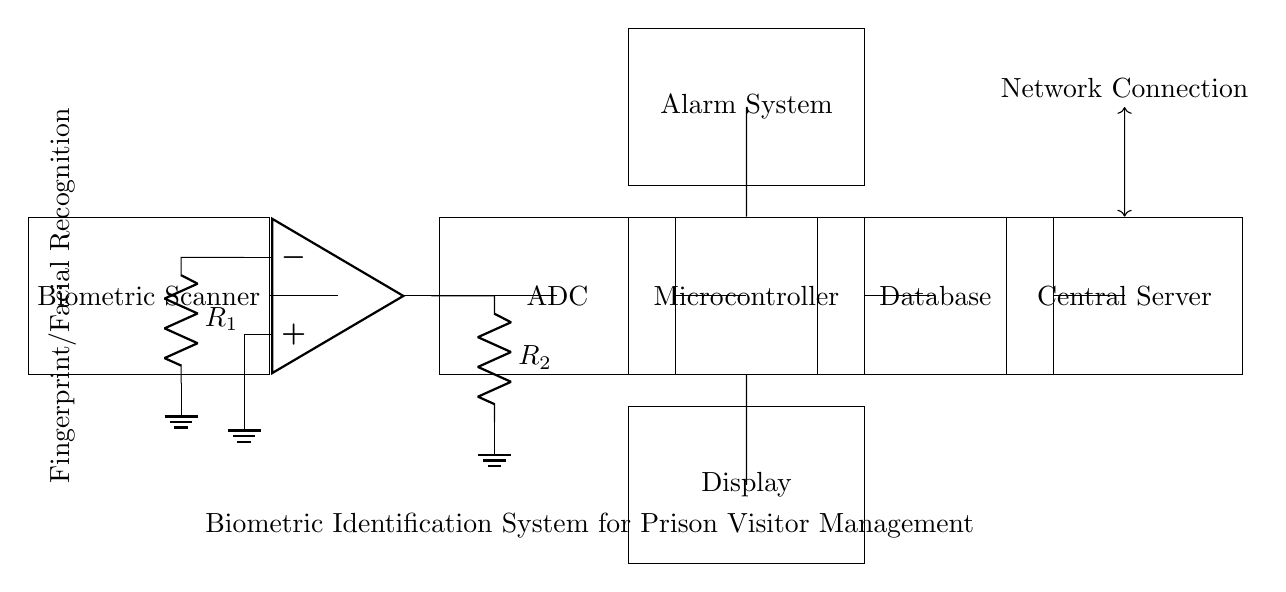What is the first component in the circuit? The first component to appear in the circuit is the Biometric Scanner, which is responsible for capturing biometric data.
Answer: Biometric Scanner How many resistors are present in the circuit? There are two resistors labeled R1 and R2 in the circuit, which are indicated next to the operational amplifier's connections.
Answer: Two What is the output of the operational amplifier connected to? The output of the operational amplifier is connected to the ADC, which converts the analog signal from the op-amp into a digital format for processing.
Answer: ADC Which component is responsible for data storage? The database component is responsible for the storage of biometric data and visitor information processed by the microcontroller.
Answer: Database What is the function of the alarm system in this circuit? The alarm system is designed to alert security personnel of any unauthorized attempts to use biometric data or access the prison inappropriately, as indicated by its connection to the microcontroller.
Answer: Alert Explain the flow of data from the biometric scanner to the central server. The process starts with the Biometric Scanner capturing data, which is then amplified by the operational amplifier. The ADC converts the amplified analog signal into digital form for the microcontroller. The microcontroller processes the data and stores it in the database. Finally, the server receives the data over a network connection for central management and analysis.
Answer: Scanner to Op-amp to ADC to Microcontroller to Database to Server 